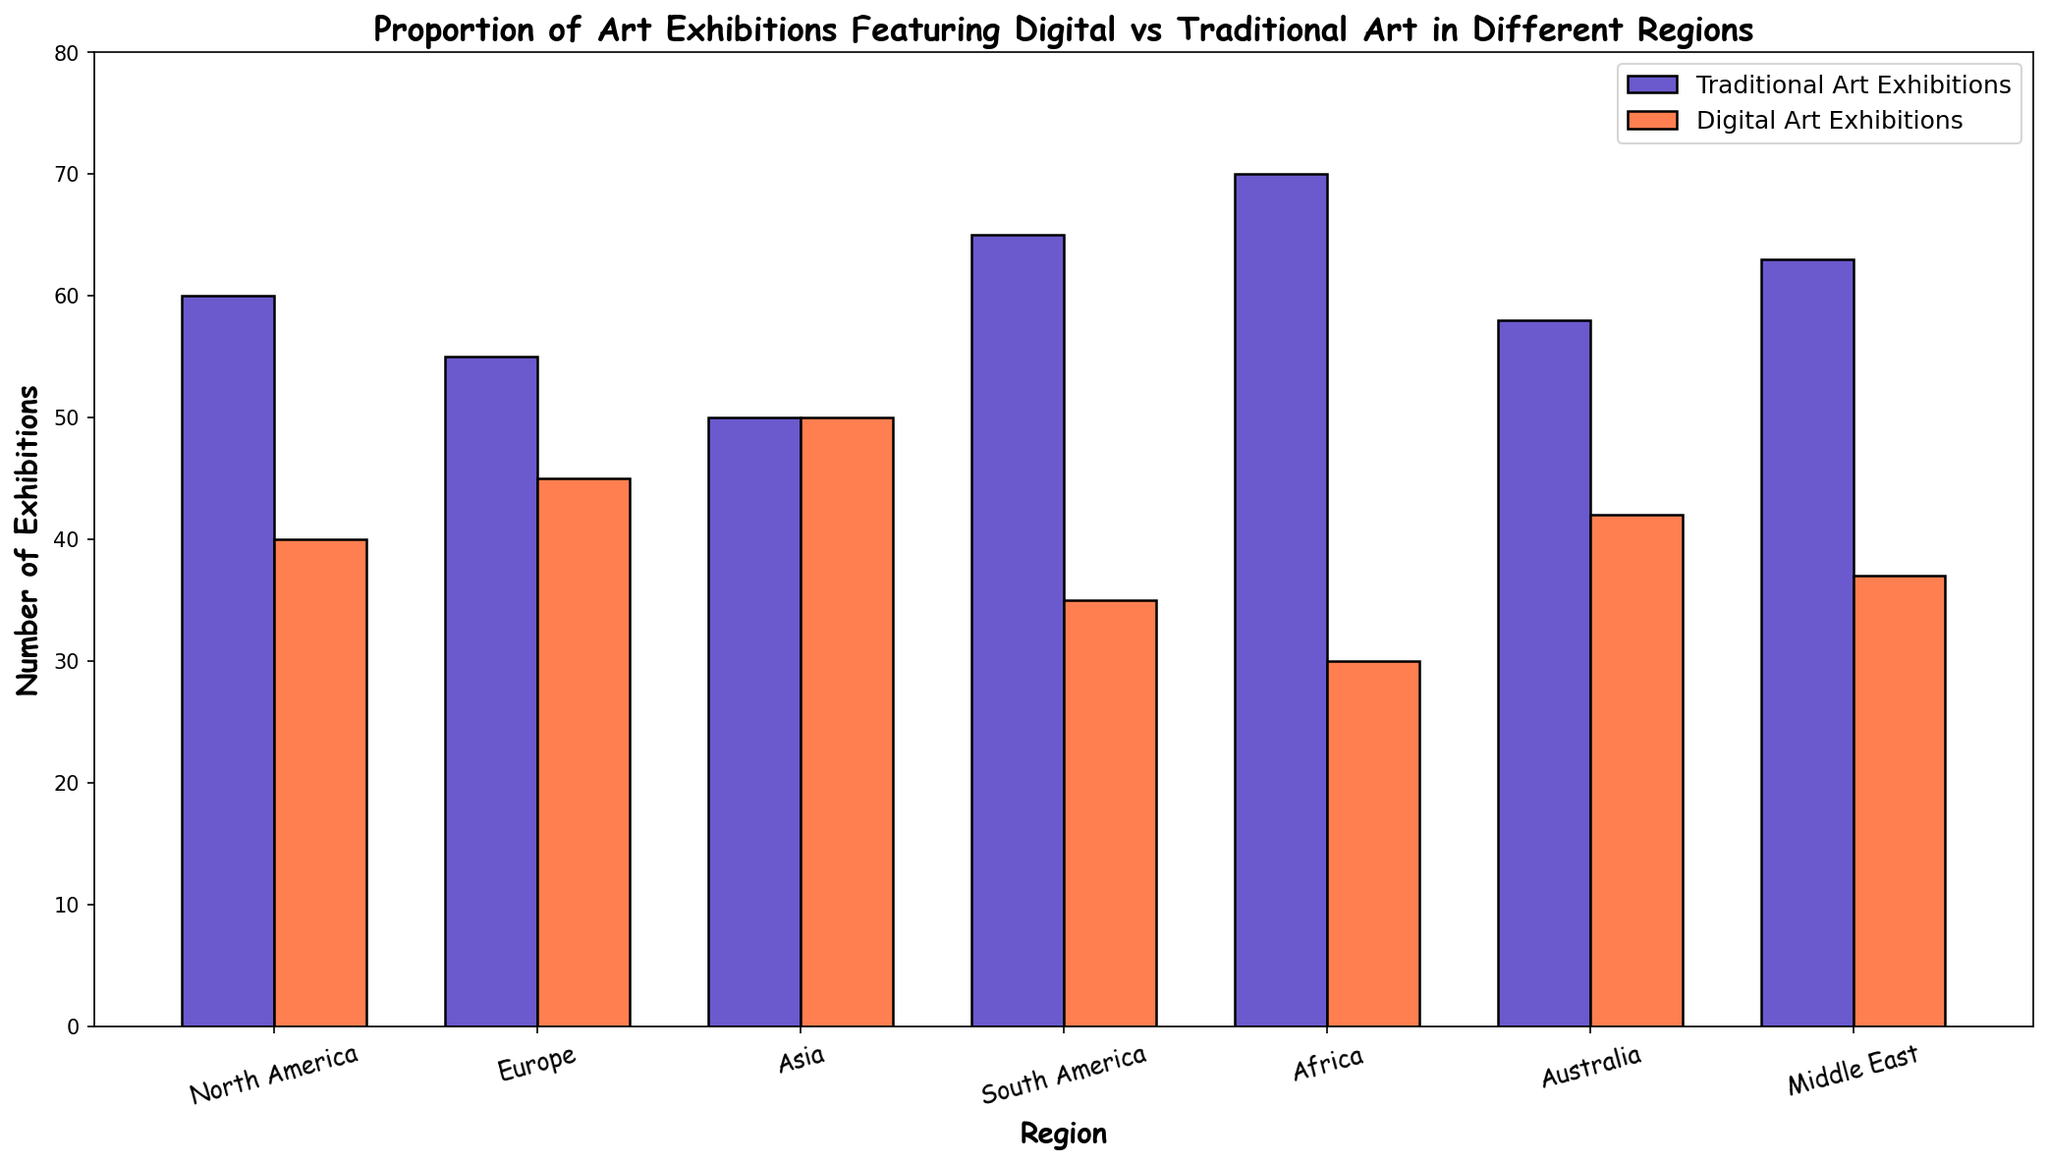What's the proportion of digital art exhibitions in Asia? In the figure, the bar for digital art exhibitions in Asia is equal to the bar for traditional art exhibitions, both having the same height of 50. This implies that the proportion is exactly 50%.
Answer: 50% Which region has the highest number of traditional art exhibitions? By comparing the heights of the bars representing traditional art exhibitions in each region, Africa has the tallest bar representing 70 exhibitions.
Answer: Africa How many more traditional art exhibitions are there in South America compared to digital art exhibitions? The figure shows that South America has 65 traditional art exhibitions and 35 digital art exhibitions. The difference is calculated by subtracting the number of digital art exhibitions from traditional art exhibitions (65 - 35 = 30).
Answer: 30 Which region has an equal number of traditional and digital art exhibitions? By examining the heights of the bars in the figure, only Asia has equal height bars for both traditional and digital art exhibitions, each having a value of 50.
Answer: Asia What is the average number of digital art exhibitions across all regions? Summing the number of digital art exhibitions across all regions (40 + 45 + 50 + 35 + 30 + 42 + 37) equals 279. Dividing by the number of regions (279 / 7) gives an average of approximately 39.86.
Answer: 39.86 Which region shows the greatest difference in exhibitions between traditional and digital art? The difference in exhibitions for each region needs to be calculated: 
- North America: 60 - 40 = 20
- Europe: 55 - 45 = 10
- Asia: 50 - 50 = 0
- South America: 65 - 35 = 30
- Africa: 70 - 30 = 40
- Australia: 58 - 42 = 16
- Middle East: 63 - 37 = 26
Africa shows the greatest difference of 40.
Answer: Africa In which regions are digital art exhibitions nearly as frequent as traditional art exhibitions? Looking for regions where the heights of the bars are close, Asia has equal exhibitions (50 each), Europe (55 vs 45), and North America (60 vs 40) have relatively close numbers.
Answer: Asia, Europe, and North America 